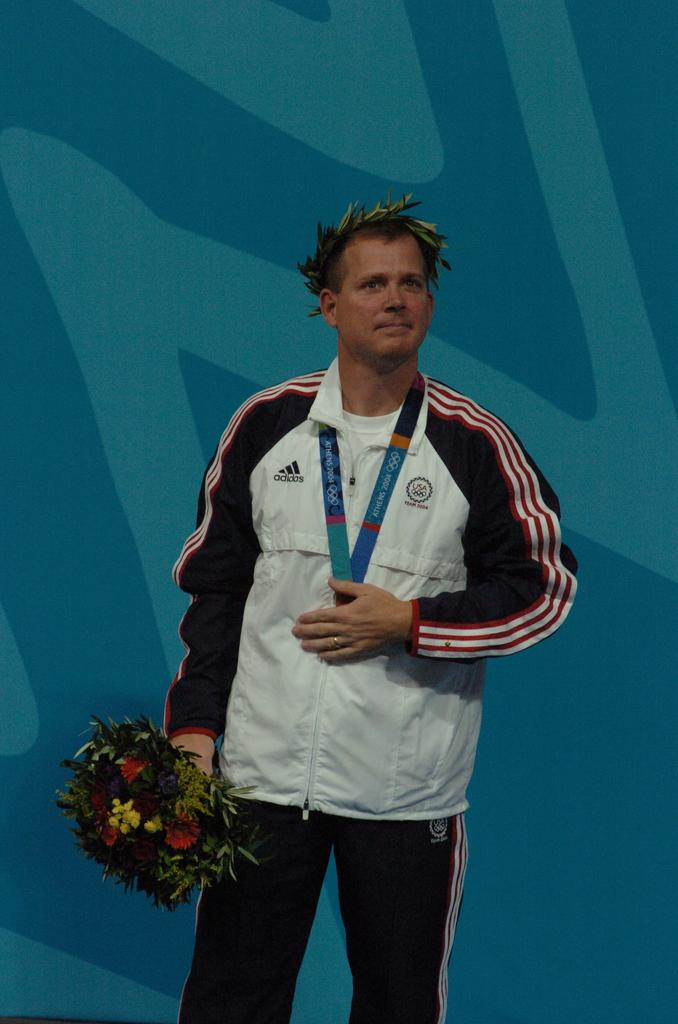<image>
Write a terse but informative summary of the picture. a winner in the athens 2004 olympics holding flowers 